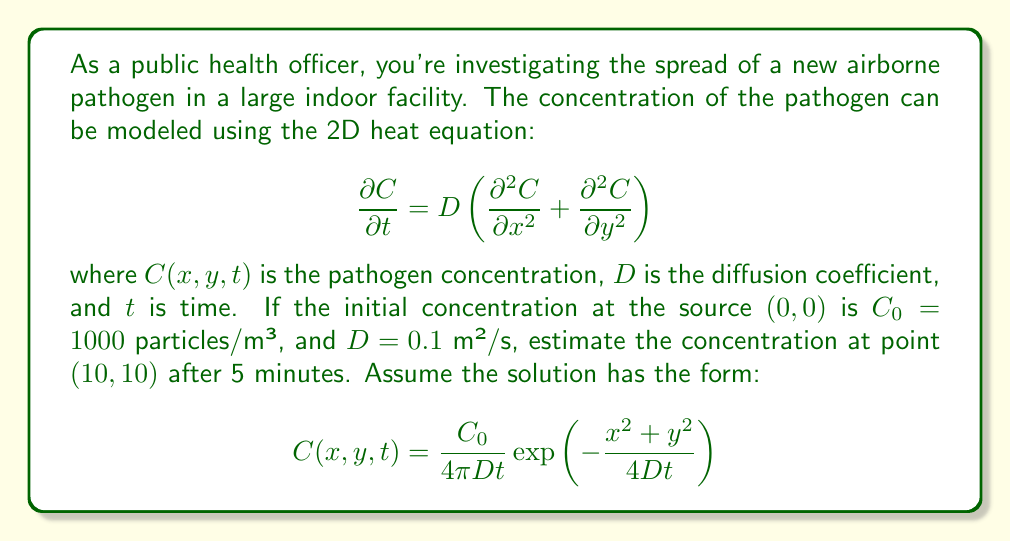Show me your answer to this math problem. To solve this problem, we'll follow these steps:

1) We have the solution form:
   $$C(x,y,t) = \frac{C_0}{4\pi Dt} \exp\left(-\frac{x^2+y^2}{4Dt}\right)$$

2) Given values:
   $C_0 = 1000$ particles/m³
   $D = 0.1$ m²/s
   $x = y = 10$ m
   $t = 5$ minutes = 300 seconds

3) Let's substitute these values into the equation:

   $$C(10,10,300) = \frac{1000}{4\pi(0.1)(300)} \exp\left(-\frac{10^2+10^2}{4(0.1)(300)}\right)$$

4) Simplify the fraction in the exponent:
   $$\frac{10^2+10^2}{4(0.1)(300)} = \frac{200}{120} = \frac{5}{3}$$

5) Now our equation looks like:
   $$C(10,10,300) = \frac{1000}{120\pi} \exp\left(-\frac{5}{3}\right)$$

6) Calculate the exponential term:
   $$\exp\left(-\frac{5}{3}\right) \approx 0.1889$$

7) Now we can compute the final result:
   $$C(10,10,300) = \frac{1000}{120\pi} (0.1889) \approx 0.5$$
Answer: $0.5$ particles/m³ 